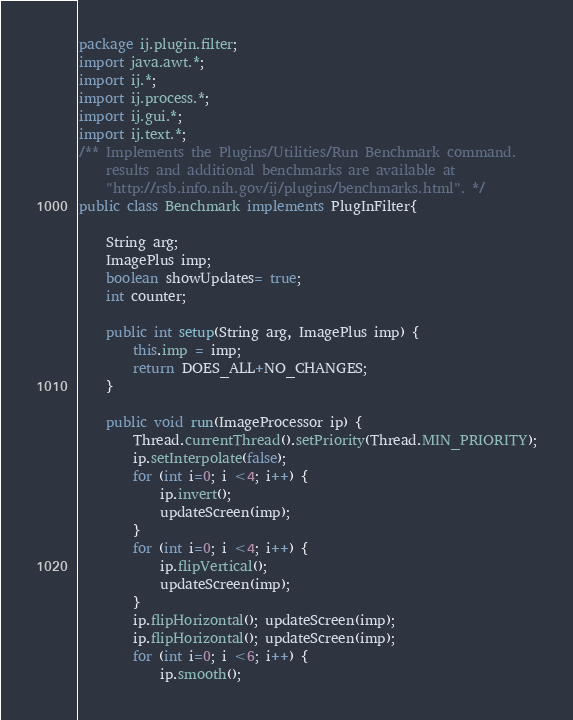Convert code to text. <code><loc_0><loc_0><loc_500><loc_500><_Java_>package ij.plugin.filter;
import java.awt.*;
import ij.*;
import ij.process.*;
import ij.gui.*;
import ij.text.*;
/** Implements the Plugins/Utilities/Run Benchmark command. 
	results and additional benchmarks are available at 
	"http://rsb.info.nih.gov/ij/plugins/benchmarks.html". */
public class Benchmark implements PlugInFilter{

	String arg;
	ImagePlus imp;
	boolean showUpdates= true;
	int counter;
	
	public int setup(String arg, ImagePlus imp) {
		this.imp = imp;
		return DOES_ALL+NO_CHANGES;
	}

	public void run(ImageProcessor ip) {
		Thread.currentThread().setPriority(Thread.MIN_PRIORITY);
		ip.setInterpolate(false);
		for (int i=0; i <4; i++) {
			ip.invert();
			updateScreen(imp);
		}
		for (int i=0; i <4; i++) {
			ip.flipVertical();
			updateScreen(imp);
		}
		ip.flipHorizontal(); updateScreen(imp);
		ip.flipHorizontal(); updateScreen(imp);
		for (int i=0; i <6; i++) {
			ip.smooth();</code> 